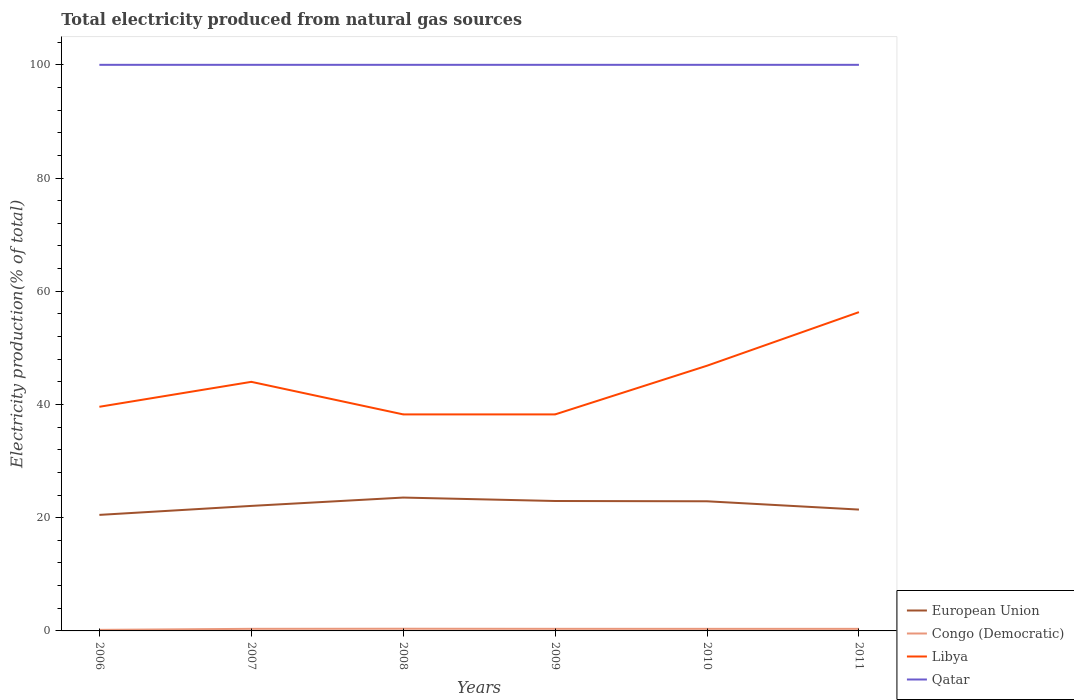How many different coloured lines are there?
Make the answer very short. 4. Does the line corresponding to Libya intersect with the line corresponding to European Union?
Ensure brevity in your answer.  No. Across all years, what is the maximum total electricity produced in European Union?
Provide a succinct answer. 20.5. In which year was the total electricity produced in European Union maximum?
Make the answer very short. 2006. What is the total total electricity produced in European Union in the graph?
Offer a very short reply. 0.66. What is the difference between the highest and the second highest total electricity produced in Qatar?
Give a very brief answer. 0. What is the difference between the highest and the lowest total electricity produced in European Union?
Provide a short and direct response. 3. Is the total electricity produced in Congo (Democratic) strictly greater than the total electricity produced in Libya over the years?
Provide a short and direct response. Yes. How many years are there in the graph?
Provide a short and direct response. 6. Are the values on the major ticks of Y-axis written in scientific E-notation?
Ensure brevity in your answer.  No. Where does the legend appear in the graph?
Your answer should be compact. Bottom right. How are the legend labels stacked?
Ensure brevity in your answer.  Vertical. What is the title of the graph?
Provide a short and direct response. Total electricity produced from natural gas sources. Does "Germany" appear as one of the legend labels in the graph?
Make the answer very short. No. What is the label or title of the X-axis?
Your response must be concise. Years. What is the Electricity production(% of total) in European Union in 2006?
Your response must be concise. 20.5. What is the Electricity production(% of total) of Congo (Democratic) in 2006?
Make the answer very short. 0.19. What is the Electricity production(% of total) in Libya in 2006?
Offer a very short reply. 39.59. What is the Electricity production(% of total) of Qatar in 2006?
Your response must be concise. 100. What is the Electricity production(% of total) in European Union in 2007?
Make the answer very short. 22.08. What is the Electricity production(% of total) in Congo (Democratic) in 2007?
Ensure brevity in your answer.  0.37. What is the Electricity production(% of total) in Libya in 2007?
Your response must be concise. 44. What is the Electricity production(% of total) in Qatar in 2007?
Ensure brevity in your answer.  100. What is the Electricity production(% of total) in European Union in 2008?
Provide a succinct answer. 23.56. What is the Electricity production(% of total) in Congo (Democratic) in 2008?
Your answer should be compact. 0.39. What is the Electricity production(% of total) of Libya in 2008?
Provide a succinct answer. 38.25. What is the Electricity production(% of total) of Qatar in 2008?
Your response must be concise. 100. What is the Electricity production(% of total) in European Union in 2009?
Make the answer very short. 22.95. What is the Electricity production(% of total) of Congo (Democratic) in 2009?
Your response must be concise. 0.37. What is the Electricity production(% of total) in Libya in 2009?
Provide a succinct answer. 38.25. What is the Electricity production(% of total) of European Union in 2010?
Make the answer very short. 22.9. What is the Electricity production(% of total) in Congo (Democratic) in 2010?
Ensure brevity in your answer.  0.37. What is the Electricity production(% of total) of Libya in 2010?
Keep it short and to the point. 46.85. What is the Electricity production(% of total) in Qatar in 2010?
Give a very brief answer. 100. What is the Electricity production(% of total) of European Union in 2011?
Your answer should be very brief. 21.43. What is the Electricity production(% of total) in Congo (Democratic) in 2011?
Make the answer very short. 0.37. What is the Electricity production(% of total) in Libya in 2011?
Offer a very short reply. 56.31. What is the Electricity production(% of total) of Qatar in 2011?
Your answer should be compact. 100. Across all years, what is the maximum Electricity production(% of total) in European Union?
Offer a terse response. 23.56. Across all years, what is the maximum Electricity production(% of total) of Congo (Democratic)?
Offer a very short reply. 0.39. Across all years, what is the maximum Electricity production(% of total) of Libya?
Provide a succinct answer. 56.31. Across all years, what is the maximum Electricity production(% of total) in Qatar?
Provide a short and direct response. 100. Across all years, what is the minimum Electricity production(% of total) in European Union?
Ensure brevity in your answer.  20.5. Across all years, what is the minimum Electricity production(% of total) in Congo (Democratic)?
Your response must be concise. 0.19. Across all years, what is the minimum Electricity production(% of total) in Libya?
Keep it short and to the point. 38.25. What is the total Electricity production(% of total) in European Union in the graph?
Your answer should be very brief. 133.42. What is the total Electricity production(% of total) in Congo (Democratic) in the graph?
Your answer should be very brief. 2.05. What is the total Electricity production(% of total) in Libya in the graph?
Provide a succinct answer. 263.25. What is the total Electricity production(% of total) in Qatar in the graph?
Keep it short and to the point. 600. What is the difference between the Electricity production(% of total) in European Union in 2006 and that in 2007?
Provide a succinct answer. -1.59. What is the difference between the Electricity production(% of total) in Congo (Democratic) in 2006 and that in 2007?
Your answer should be very brief. -0.18. What is the difference between the Electricity production(% of total) in Libya in 2006 and that in 2007?
Provide a succinct answer. -4.41. What is the difference between the Electricity production(% of total) in European Union in 2006 and that in 2008?
Offer a terse response. -3.06. What is the difference between the Electricity production(% of total) of Congo (Democratic) in 2006 and that in 2008?
Your answer should be very brief. -0.2. What is the difference between the Electricity production(% of total) in Libya in 2006 and that in 2008?
Provide a succinct answer. 1.35. What is the difference between the Electricity production(% of total) in European Union in 2006 and that in 2009?
Your answer should be compact. -2.45. What is the difference between the Electricity production(% of total) of Congo (Democratic) in 2006 and that in 2009?
Provide a succinct answer. -0.18. What is the difference between the Electricity production(% of total) in Libya in 2006 and that in 2009?
Keep it short and to the point. 1.35. What is the difference between the Electricity production(% of total) of Qatar in 2006 and that in 2009?
Offer a terse response. 0. What is the difference between the Electricity production(% of total) of European Union in 2006 and that in 2010?
Make the answer very short. -2.4. What is the difference between the Electricity production(% of total) in Congo (Democratic) in 2006 and that in 2010?
Your answer should be very brief. -0.18. What is the difference between the Electricity production(% of total) of Libya in 2006 and that in 2010?
Keep it short and to the point. -7.25. What is the difference between the Electricity production(% of total) of European Union in 2006 and that in 2011?
Give a very brief answer. -0.94. What is the difference between the Electricity production(% of total) in Congo (Democratic) in 2006 and that in 2011?
Your answer should be compact. -0.18. What is the difference between the Electricity production(% of total) of Libya in 2006 and that in 2011?
Provide a succinct answer. -16.72. What is the difference between the Electricity production(% of total) in Qatar in 2006 and that in 2011?
Make the answer very short. 0. What is the difference between the Electricity production(% of total) of European Union in 2007 and that in 2008?
Give a very brief answer. -1.47. What is the difference between the Electricity production(% of total) of Congo (Democratic) in 2007 and that in 2008?
Offer a very short reply. -0.02. What is the difference between the Electricity production(% of total) in Libya in 2007 and that in 2008?
Provide a succinct answer. 5.75. What is the difference between the Electricity production(% of total) of European Union in 2007 and that in 2009?
Make the answer very short. -0.87. What is the difference between the Electricity production(% of total) of Congo (Democratic) in 2007 and that in 2009?
Make the answer very short. -0. What is the difference between the Electricity production(% of total) of Libya in 2007 and that in 2009?
Your response must be concise. 5.75. What is the difference between the Electricity production(% of total) in European Union in 2007 and that in 2010?
Make the answer very short. -0.82. What is the difference between the Electricity production(% of total) of Congo (Democratic) in 2007 and that in 2010?
Your answer should be compact. 0. What is the difference between the Electricity production(% of total) of Libya in 2007 and that in 2010?
Offer a very short reply. -2.85. What is the difference between the Electricity production(% of total) in European Union in 2007 and that in 2011?
Your answer should be very brief. 0.65. What is the difference between the Electricity production(% of total) of Congo (Democratic) in 2007 and that in 2011?
Your answer should be very brief. 0. What is the difference between the Electricity production(% of total) in Libya in 2007 and that in 2011?
Keep it short and to the point. -12.31. What is the difference between the Electricity production(% of total) of Qatar in 2007 and that in 2011?
Offer a very short reply. 0. What is the difference between the Electricity production(% of total) in European Union in 2008 and that in 2009?
Provide a succinct answer. 0.61. What is the difference between the Electricity production(% of total) in Congo (Democratic) in 2008 and that in 2009?
Ensure brevity in your answer.  0.01. What is the difference between the Electricity production(% of total) of Libya in 2008 and that in 2009?
Offer a very short reply. -0. What is the difference between the Electricity production(% of total) of European Union in 2008 and that in 2010?
Give a very brief answer. 0.66. What is the difference between the Electricity production(% of total) of Congo (Democratic) in 2008 and that in 2010?
Give a very brief answer. 0.02. What is the difference between the Electricity production(% of total) in Libya in 2008 and that in 2010?
Provide a succinct answer. -8.6. What is the difference between the Electricity production(% of total) of European Union in 2008 and that in 2011?
Your answer should be very brief. 2.12. What is the difference between the Electricity production(% of total) of Congo (Democratic) in 2008 and that in 2011?
Your response must be concise. 0.02. What is the difference between the Electricity production(% of total) of Libya in 2008 and that in 2011?
Offer a terse response. -18.06. What is the difference between the Electricity production(% of total) of Qatar in 2008 and that in 2011?
Make the answer very short. 0. What is the difference between the Electricity production(% of total) of European Union in 2009 and that in 2010?
Your answer should be compact. 0.05. What is the difference between the Electricity production(% of total) in Congo (Democratic) in 2009 and that in 2010?
Make the answer very short. 0. What is the difference between the Electricity production(% of total) in Libya in 2009 and that in 2010?
Provide a succinct answer. -8.6. What is the difference between the Electricity production(% of total) of European Union in 2009 and that in 2011?
Your answer should be compact. 1.52. What is the difference between the Electricity production(% of total) in Congo (Democratic) in 2009 and that in 2011?
Provide a short and direct response. 0. What is the difference between the Electricity production(% of total) of Libya in 2009 and that in 2011?
Your response must be concise. -18.06. What is the difference between the Electricity production(% of total) of Qatar in 2009 and that in 2011?
Make the answer very short. 0. What is the difference between the Electricity production(% of total) of European Union in 2010 and that in 2011?
Offer a terse response. 1.47. What is the difference between the Electricity production(% of total) of Congo (Democratic) in 2010 and that in 2011?
Offer a terse response. -0. What is the difference between the Electricity production(% of total) in Libya in 2010 and that in 2011?
Give a very brief answer. -9.46. What is the difference between the Electricity production(% of total) of Qatar in 2010 and that in 2011?
Provide a succinct answer. 0. What is the difference between the Electricity production(% of total) in European Union in 2006 and the Electricity production(% of total) in Congo (Democratic) in 2007?
Give a very brief answer. 20.13. What is the difference between the Electricity production(% of total) of European Union in 2006 and the Electricity production(% of total) of Libya in 2007?
Offer a terse response. -23.5. What is the difference between the Electricity production(% of total) in European Union in 2006 and the Electricity production(% of total) in Qatar in 2007?
Provide a succinct answer. -79.5. What is the difference between the Electricity production(% of total) of Congo (Democratic) in 2006 and the Electricity production(% of total) of Libya in 2007?
Offer a very short reply. -43.81. What is the difference between the Electricity production(% of total) in Congo (Democratic) in 2006 and the Electricity production(% of total) in Qatar in 2007?
Make the answer very short. -99.81. What is the difference between the Electricity production(% of total) of Libya in 2006 and the Electricity production(% of total) of Qatar in 2007?
Give a very brief answer. -60.41. What is the difference between the Electricity production(% of total) in European Union in 2006 and the Electricity production(% of total) in Congo (Democratic) in 2008?
Give a very brief answer. 20.11. What is the difference between the Electricity production(% of total) in European Union in 2006 and the Electricity production(% of total) in Libya in 2008?
Your answer should be very brief. -17.75. What is the difference between the Electricity production(% of total) in European Union in 2006 and the Electricity production(% of total) in Qatar in 2008?
Give a very brief answer. -79.5. What is the difference between the Electricity production(% of total) in Congo (Democratic) in 2006 and the Electricity production(% of total) in Libya in 2008?
Offer a terse response. -38.06. What is the difference between the Electricity production(% of total) in Congo (Democratic) in 2006 and the Electricity production(% of total) in Qatar in 2008?
Ensure brevity in your answer.  -99.81. What is the difference between the Electricity production(% of total) of Libya in 2006 and the Electricity production(% of total) of Qatar in 2008?
Offer a terse response. -60.41. What is the difference between the Electricity production(% of total) in European Union in 2006 and the Electricity production(% of total) in Congo (Democratic) in 2009?
Your answer should be compact. 20.13. What is the difference between the Electricity production(% of total) of European Union in 2006 and the Electricity production(% of total) of Libya in 2009?
Provide a succinct answer. -17.75. What is the difference between the Electricity production(% of total) in European Union in 2006 and the Electricity production(% of total) in Qatar in 2009?
Keep it short and to the point. -79.5. What is the difference between the Electricity production(% of total) in Congo (Democratic) in 2006 and the Electricity production(% of total) in Libya in 2009?
Keep it short and to the point. -38.06. What is the difference between the Electricity production(% of total) in Congo (Democratic) in 2006 and the Electricity production(% of total) in Qatar in 2009?
Ensure brevity in your answer.  -99.81. What is the difference between the Electricity production(% of total) of Libya in 2006 and the Electricity production(% of total) of Qatar in 2009?
Offer a very short reply. -60.41. What is the difference between the Electricity production(% of total) in European Union in 2006 and the Electricity production(% of total) in Congo (Democratic) in 2010?
Provide a short and direct response. 20.13. What is the difference between the Electricity production(% of total) of European Union in 2006 and the Electricity production(% of total) of Libya in 2010?
Ensure brevity in your answer.  -26.35. What is the difference between the Electricity production(% of total) of European Union in 2006 and the Electricity production(% of total) of Qatar in 2010?
Provide a short and direct response. -79.5. What is the difference between the Electricity production(% of total) of Congo (Democratic) in 2006 and the Electricity production(% of total) of Libya in 2010?
Your response must be concise. -46.66. What is the difference between the Electricity production(% of total) of Congo (Democratic) in 2006 and the Electricity production(% of total) of Qatar in 2010?
Provide a short and direct response. -99.81. What is the difference between the Electricity production(% of total) of Libya in 2006 and the Electricity production(% of total) of Qatar in 2010?
Provide a succinct answer. -60.41. What is the difference between the Electricity production(% of total) of European Union in 2006 and the Electricity production(% of total) of Congo (Democratic) in 2011?
Make the answer very short. 20.13. What is the difference between the Electricity production(% of total) in European Union in 2006 and the Electricity production(% of total) in Libya in 2011?
Give a very brief answer. -35.81. What is the difference between the Electricity production(% of total) of European Union in 2006 and the Electricity production(% of total) of Qatar in 2011?
Offer a terse response. -79.5. What is the difference between the Electricity production(% of total) of Congo (Democratic) in 2006 and the Electricity production(% of total) of Libya in 2011?
Provide a short and direct response. -56.13. What is the difference between the Electricity production(% of total) in Congo (Democratic) in 2006 and the Electricity production(% of total) in Qatar in 2011?
Your answer should be very brief. -99.81. What is the difference between the Electricity production(% of total) in Libya in 2006 and the Electricity production(% of total) in Qatar in 2011?
Make the answer very short. -60.41. What is the difference between the Electricity production(% of total) of European Union in 2007 and the Electricity production(% of total) of Congo (Democratic) in 2008?
Ensure brevity in your answer.  21.7. What is the difference between the Electricity production(% of total) of European Union in 2007 and the Electricity production(% of total) of Libya in 2008?
Make the answer very short. -16.16. What is the difference between the Electricity production(% of total) in European Union in 2007 and the Electricity production(% of total) in Qatar in 2008?
Your answer should be very brief. -77.92. What is the difference between the Electricity production(% of total) in Congo (Democratic) in 2007 and the Electricity production(% of total) in Libya in 2008?
Provide a short and direct response. -37.88. What is the difference between the Electricity production(% of total) of Congo (Democratic) in 2007 and the Electricity production(% of total) of Qatar in 2008?
Provide a succinct answer. -99.63. What is the difference between the Electricity production(% of total) of Libya in 2007 and the Electricity production(% of total) of Qatar in 2008?
Your response must be concise. -56. What is the difference between the Electricity production(% of total) in European Union in 2007 and the Electricity production(% of total) in Congo (Democratic) in 2009?
Ensure brevity in your answer.  21.71. What is the difference between the Electricity production(% of total) in European Union in 2007 and the Electricity production(% of total) in Libya in 2009?
Give a very brief answer. -16.16. What is the difference between the Electricity production(% of total) in European Union in 2007 and the Electricity production(% of total) in Qatar in 2009?
Make the answer very short. -77.92. What is the difference between the Electricity production(% of total) in Congo (Democratic) in 2007 and the Electricity production(% of total) in Libya in 2009?
Your answer should be very brief. -37.88. What is the difference between the Electricity production(% of total) of Congo (Democratic) in 2007 and the Electricity production(% of total) of Qatar in 2009?
Ensure brevity in your answer.  -99.63. What is the difference between the Electricity production(% of total) of Libya in 2007 and the Electricity production(% of total) of Qatar in 2009?
Keep it short and to the point. -56. What is the difference between the Electricity production(% of total) in European Union in 2007 and the Electricity production(% of total) in Congo (Democratic) in 2010?
Ensure brevity in your answer.  21.72. What is the difference between the Electricity production(% of total) in European Union in 2007 and the Electricity production(% of total) in Libya in 2010?
Offer a terse response. -24.76. What is the difference between the Electricity production(% of total) of European Union in 2007 and the Electricity production(% of total) of Qatar in 2010?
Your answer should be compact. -77.92. What is the difference between the Electricity production(% of total) in Congo (Democratic) in 2007 and the Electricity production(% of total) in Libya in 2010?
Your answer should be very brief. -46.48. What is the difference between the Electricity production(% of total) of Congo (Democratic) in 2007 and the Electricity production(% of total) of Qatar in 2010?
Make the answer very short. -99.63. What is the difference between the Electricity production(% of total) of Libya in 2007 and the Electricity production(% of total) of Qatar in 2010?
Your response must be concise. -56. What is the difference between the Electricity production(% of total) of European Union in 2007 and the Electricity production(% of total) of Congo (Democratic) in 2011?
Keep it short and to the point. 21.72. What is the difference between the Electricity production(% of total) in European Union in 2007 and the Electricity production(% of total) in Libya in 2011?
Provide a short and direct response. -34.23. What is the difference between the Electricity production(% of total) in European Union in 2007 and the Electricity production(% of total) in Qatar in 2011?
Your response must be concise. -77.92. What is the difference between the Electricity production(% of total) in Congo (Democratic) in 2007 and the Electricity production(% of total) in Libya in 2011?
Provide a succinct answer. -55.94. What is the difference between the Electricity production(% of total) of Congo (Democratic) in 2007 and the Electricity production(% of total) of Qatar in 2011?
Your response must be concise. -99.63. What is the difference between the Electricity production(% of total) of Libya in 2007 and the Electricity production(% of total) of Qatar in 2011?
Offer a very short reply. -56. What is the difference between the Electricity production(% of total) in European Union in 2008 and the Electricity production(% of total) in Congo (Democratic) in 2009?
Keep it short and to the point. 23.19. What is the difference between the Electricity production(% of total) of European Union in 2008 and the Electricity production(% of total) of Libya in 2009?
Give a very brief answer. -14.69. What is the difference between the Electricity production(% of total) of European Union in 2008 and the Electricity production(% of total) of Qatar in 2009?
Your answer should be very brief. -76.44. What is the difference between the Electricity production(% of total) of Congo (Democratic) in 2008 and the Electricity production(% of total) of Libya in 2009?
Provide a short and direct response. -37.86. What is the difference between the Electricity production(% of total) of Congo (Democratic) in 2008 and the Electricity production(% of total) of Qatar in 2009?
Provide a short and direct response. -99.61. What is the difference between the Electricity production(% of total) of Libya in 2008 and the Electricity production(% of total) of Qatar in 2009?
Your answer should be compact. -61.75. What is the difference between the Electricity production(% of total) in European Union in 2008 and the Electricity production(% of total) in Congo (Democratic) in 2010?
Make the answer very short. 23.19. What is the difference between the Electricity production(% of total) of European Union in 2008 and the Electricity production(% of total) of Libya in 2010?
Your answer should be very brief. -23.29. What is the difference between the Electricity production(% of total) of European Union in 2008 and the Electricity production(% of total) of Qatar in 2010?
Keep it short and to the point. -76.44. What is the difference between the Electricity production(% of total) in Congo (Democratic) in 2008 and the Electricity production(% of total) in Libya in 2010?
Give a very brief answer. -46.46. What is the difference between the Electricity production(% of total) of Congo (Democratic) in 2008 and the Electricity production(% of total) of Qatar in 2010?
Your answer should be compact. -99.61. What is the difference between the Electricity production(% of total) of Libya in 2008 and the Electricity production(% of total) of Qatar in 2010?
Offer a terse response. -61.75. What is the difference between the Electricity production(% of total) in European Union in 2008 and the Electricity production(% of total) in Congo (Democratic) in 2011?
Make the answer very short. 23.19. What is the difference between the Electricity production(% of total) of European Union in 2008 and the Electricity production(% of total) of Libya in 2011?
Offer a very short reply. -32.76. What is the difference between the Electricity production(% of total) of European Union in 2008 and the Electricity production(% of total) of Qatar in 2011?
Provide a short and direct response. -76.44. What is the difference between the Electricity production(% of total) in Congo (Democratic) in 2008 and the Electricity production(% of total) in Libya in 2011?
Your answer should be very brief. -55.93. What is the difference between the Electricity production(% of total) of Congo (Democratic) in 2008 and the Electricity production(% of total) of Qatar in 2011?
Your answer should be compact. -99.61. What is the difference between the Electricity production(% of total) of Libya in 2008 and the Electricity production(% of total) of Qatar in 2011?
Offer a terse response. -61.75. What is the difference between the Electricity production(% of total) of European Union in 2009 and the Electricity production(% of total) of Congo (Democratic) in 2010?
Offer a terse response. 22.58. What is the difference between the Electricity production(% of total) in European Union in 2009 and the Electricity production(% of total) in Libya in 2010?
Make the answer very short. -23.9. What is the difference between the Electricity production(% of total) of European Union in 2009 and the Electricity production(% of total) of Qatar in 2010?
Give a very brief answer. -77.05. What is the difference between the Electricity production(% of total) of Congo (Democratic) in 2009 and the Electricity production(% of total) of Libya in 2010?
Keep it short and to the point. -46.48. What is the difference between the Electricity production(% of total) in Congo (Democratic) in 2009 and the Electricity production(% of total) in Qatar in 2010?
Keep it short and to the point. -99.63. What is the difference between the Electricity production(% of total) in Libya in 2009 and the Electricity production(% of total) in Qatar in 2010?
Make the answer very short. -61.75. What is the difference between the Electricity production(% of total) in European Union in 2009 and the Electricity production(% of total) in Congo (Democratic) in 2011?
Your answer should be very brief. 22.58. What is the difference between the Electricity production(% of total) in European Union in 2009 and the Electricity production(% of total) in Libya in 2011?
Provide a short and direct response. -33.36. What is the difference between the Electricity production(% of total) of European Union in 2009 and the Electricity production(% of total) of Qatar in 2011?
Ensure brevity in your answer.  -77.05. What is the difference between the Electricity production(% of total) of Congo (Democratic) in 2009 and the Electricity production(% of total) of Libya in 2011?
Provide a short and direct response. -55.94. What is the difference between the Electricity production(% of total) of Congo (Democratic) in 2009 and the Electricity production(% of total) of Qatar in 2011?
Offer a terse response. -99.63. What is the difference between the Electricity production(% of total) in Libya in 2009 and the Electricity production(% of total) in Qatar in 2011?
Offer a very short reply. -61.75. What is the difference between the Electricity production(% of total) of European Union in 2010 and the Electricity production(% of total) of Congo (Democratic) in 2011?
Provide a short and direct response. 22.53. What is the difference between the Electricity production(% of total) in European Union in 2010 and the Electricity production(% of total) in Libya in 2011?
Provide a succinct answer. -33.41. What is the difference between the Electricity production(% of total) in European Union in 2010 and the Electricity production(% of total) in Qatar in 2011?
Make the answer very short. -77.1. What is the difference between the Electricity production(% of total) of Congo (Democratic) in 2010 and the Electricity production(% of total) of Libya in 2011?
Provide a succinct answer. -55.94. What is the difference between the Electricity production(% of total) of Congo (Democratic) in 2010 and the Electricity production(% of total) of Qatar in 2011?
Ensure brevity in your answer.  -99.63. What is the difference between the Electricity production(% of total) of Libya in 2010 and the Electricity production(% of total) of Qatar in 2011?
Your response must be concise. -53.15. What is the average Electricity production(% of total) in European Union per year?
Offer a terse response. 22.24. What is the average Electricity production(% of total) in Congo (Democratic) per year?
Your answer should be very brief. 0.34. What is the average Electricity production(% of total) in Libya per year?
Offer a very short reply. 43.87. What is the average Electricity production(% of total) of Qatar per year?
Offer a very short reply. 100. In the year 2006, what is the difference between the Electricity production(% of total) of European Union and Electricity production(% of total) of Congo (Democratic)?
Ensure brevity in your answer.  20.31. In the year 2006, what is the difference between the Electricity production(% of total) in European Union and Electricity production(% of total) in Libya?
Make the answer very short. -19.1. In the year 2006, what is the difference between the Electricity production(% of total) of European Union and Electricity production(% of total) of Qatar?
Your answer should be compact. -79.5. In the year 2006, what is the difference between the Electricity production(% of total) of Congo (Democratic) and Electricity production(% of total) of Libya?
Your response must be concise. -39.41. In the year 2006, what is the difference between the Electricity production(% of total) of Congo (Democratic) and Electricity production(% of total) of Qatar?
Provide a short and direct response. -99.81. In the year 2006, what is the difference between the Electricity production(% of total) in Libya and Electricity production(% of total) in Qatar?
Your answer should be compact. -60.41. In the year 2007, what is the difference between the Electricity production(% of total) of European Union and Electricity production(% of total) of Congo (Democratic)?
Your answer should be compact. 21.71. In the year 2007, what is the difference between the Electricity production(% of total) of European Union and Electricity production(% of total) of Libya?
Offer a very short reply. -21.92. In the year 2007, what is the difference between the Electricity production(% of total) in European Union and Electricity production(% of total) in Qatar?
Provide a short and direct response. -77.92. In the year 2007, what is the difference between the Electricity production(% of total) in Congo (Democratic) and Electricity production(% of total) in Libya?
Make the answer very short. -43.63. In the year 2007, what is the difference between the Electricity production(% of total) of Congo (Democratic) and Electricity production(% of total) of Qatar?
Give a very brief answer. -99.63. In the year 2007, what is the difference between the Electricity production(% of total) of Libya and Electricity production(% of total) of Qatar?
Your answer should be compact. -56. In the year 2008, what is the difference between the Electricity production(% of total) in European Union and Electricity production(% of total) in Congo (Democratic)?
Your response must be concise. 23.17. In the year 2008, what is the difference between the Electricity production(% of total) in European Union and Electricity production(% of total) in Libya?
Your answer should be compact. -14.69. In the year 2008, what is the difference between the Electricity production(% of total) of European Union and Electricity production(% of total) of Qatar?
Provide a succinct answer. -76.44. In the year 2008, what is the difference between the Electricity production(% of total) of Congo (Democratic) and Electricity production(% of total) of Libya?
Your answer should be very brief. -37.86. In the year 2008, what is the difference between the Electricity production(% of total) of Congo (Democratic) and Electricity production(% of total) of Qatar?
Provide a short and direct response. -99.61. In the year 2008, what is the difference between the Electricity production(% of total) of Libya and Electricity production(% of total) of Qatar?
Provide a short and direct response. -61.75. In the year 2009, what is the difference between the Electricity production(% of total) of European Union and Electricity production(% of total) of Congo (Democratic)?
Give a very brief answer. 22.58. In the year 2009, what is the difference between the Electricity production(% of total) in European Union and Electricity production(% of total) in Libya?
Give a very brief answer. -15.3. In the year 2009, what is the difference between the Electricity production(% of total) of European Union and Electricity production(% of total) of Qatar?
Provide a succinct answer. -77.05. In the year 2009, what is the difference between the Electricity production(% of total) of Congo (Democratic) and Electricity production(% of total) of Libya?
Your answer should be very brief. -37.88. In the year 2009, what is the difference between the Electricity production(% of total) in Congo (Democratic) and Electricity production(% of total) in Qatar?
Provide a short and direct response. -99.63. In the year 2009, what is the difference between the Electricity production(% of total) in Libya and Electricity production(% of total) in Qatar?
Provide a short and direct response. -61.75. In the year 2010, what is the difference between the Electricity production(% of total) in European Union and Electricity production(% of total) in Congo (Democratic)?
Offer a very short reply. 22.53. In the year 2010, what is the difference between the Electricity production(% of total) in European Union and Electricity production(% of total) in Libya?
Ensure brevity in your answer.  -23.95. In the year 2010, what is the difference between the Electricity production(% of total) in European Union and Electricity production(% of total) in Qatar?
Provide a short and direct response. -77.1. In the year 2010, what is the difference between the Electricity production(% of total) in Congo (Democratic) and Electricity production(% of total) in Libya?
Offer a very short reply. -46.48. In the year 2010, what is the difference between the Electricity production(% of total) of Congo (Democratic) and Electricity production(% of total) of Qatar?
Provide a short and direct response. -99.63. In the year 2010, what is the difference between the Electricity production(% of total) of Libya and Electricity production(% of total) of Qatar?
Make the answer very short. -53.15. In the year 2011, what is the difference between the Electricity production(% of total) in European Union and Electricity production(% of total) in Congo (Democratic)?
Provide a short and direct response. 21.07. In the year 2011, what is the difference between the Electricity production(% of total) of European Union and Electricity production(% of total) of Libya?
Keep it short and to the point. -34.88. In the year 2011, what is the difference between the Electricity production(% of total) of European Union and Electricity production(% of total) of Qatar?
Your answer should be compact. -78.57. In the year 2011, what is the difference between the Electricity production(% of total) in Congo (Democratic) and Electricity production(% of total) in Libya?
Keep it short and to the point. -55.94. In the year 2011, what is the difference between the Electricity production(% of total) of Congo (Democratic) and Electricity production(% of total) of Qatar?
Your answer should be compact. -99.63. In the year 2011, what is the difference between the Electricity production(% of total) of Libya and Electricity production(% of total) of Qatar?
Ensure brevity in your answer.  -43.69. What is the ratio of the Electricity production(% of total) in European Union in 2006 to that in 2007?
Ensure brevity in your answer.  0.93. What is the ratio of the Electricity production(% of total) of Congo (Democratic) in 2006 to that in 2007?
Make the answer very short. 0.5. What is the ratio of the Electricity production(% of total) of Libya in 2006 to that in 2007?
Offer a very short reply. 0.9. What is the ratio of the Electricity production(% of total) of Qatar in 2006 to that in 2007?
Your response must be concise. 1. What is the ratio of the Electricity production(% of total) of European Union in 2006 to that in 2008?
Your answer should be very brief. 0.87. What is the ratio of the Electricity production(% of total) in Congo (Democratic) in 2006 to that in 2008?
Provide a short and direct response. 0.48. What is the ratio of the Electricity production(% of total) of Libya in 2006 to that in 2008?
Your response must be concise. 1.04. What is the ratio of the Electricity production(% of total) of Qatar in 2006 to that in 2008?
Give a very brief answer. 1. What is the ratio of the Electricity production(% of total) in European Union in 2006 to that in 2009?
Keep it short and to the point. 0.89. What is the ratio of the Electricity production(% of total) of Congo (Democratic) in 2006 to that in 2009?
Make the answer very short. 0.5. What is the ratio of the Electricity production(% of total) of Libya in 2006 to that in 2009?
Your answer should be compact. 1.04. What is the ratio of the Electricity production(% of total) of European Union in 2006 to that in 2010?
Provide a short and direct response. 0.9. What is the ratio of the Electricity production(% of total) of Congo (Democratic) in 2006 to that in 2010?
Give a very brief answer. 0.5. What is the ratio of the Electricity production(% of total) in Libya in 2006 to that in 2010?
Your answer should be compact. 0.85. What is the ratio of the Electricity production(% of total) of European Union in 2006 to that in 2011?
Give a very brief answer. 0.96. What is the ratio of the Electricity production(% of total) of Congo (Democratic) in 2006 to that in 2011?
Provide a succinct answer. 0.5. What is the ratio of the Electricity production(% of total) in Libya in 2006 to that in 2011?
Provide a succinct answer. 0.7. What is the ratio of the Electricity production(% of total) of Qatar in 2006 to that in 2011?
Your answer should be very brief. 1. What is the ratio of the Electricity production(% of total) of European Union in 2007 to that in 2008?
Offer a very short reply. 0.94. What is the ratio of the Electricity production(% of total) in Congo (Democratic) in 2007 to that in 2008?
Keep it short and to the point. 0.96. What is the ratio of the Electricity production(% of total) in Libya in 2007 to that in 2008?
Your answer should be compact. 1.15. What is the ratio of the Electricity production(% of total) of European Union in 2007 to that in 2009?
Keep it short and to the point. 0.96. What is the ratio of the Electricity production(% of total) of Libya in 2007 to that in 2009?
Keep it short and to the point. 1.15. What is the ratio of the Electricity production(% of total) in Congo (Democratic) in 2007 to that in 2010?
Keep it short and to the point. 1. What is the ratio of the Electricity production(% of total) of Libya in 2007 to that in 2010?
Your answer should be compact. 0.94. What is the ratio of the Electricity production(% of total) of Qatar in 2007 to that in 2010?
Give a very brief answer. 1. What is the ratio of the Electricity production(% of total) in European Union in 2007 to that in 2011?
Make the answer very short. 1.03. What is the ratio of the Electricity production(% of total) of Congo (Democratic) in 2007 to that in 2011?
Your answer should be compact. 1. What is the ratio of the Electricity production(% of total) in Libya in 2007 to that in 2011?
Offer a very short reply. 0.78. What is the ratio of the Electricity production(% of total) in European Union in 2008 to that in 2009?
Provide a short and direct response. 1.03. What is the ratio of the Electricity production(% of total) in Congo (Democratic) in 2008 to that in 2009?
Offer a very short reply. 1.04. What is the ratio of the Electricity production(% of total) of Libya in 2008 to that in 2009?
Ensure brevity in your answer.  1. What is the ratio of the Electricity production(% of total) of Qatar in 2008 to that in 2009?
Offer a very short reply. 1. What is the ratio of the Electricity production(% of total) in European Union in 2008 to that in 2010?
Provide a succinct answer. 1.03. What is the ratio of the Electricity production(% of total) of Congo (Democratic) in 2008 to that in 2010?
Make the answer very short. 1.05. What is the ratio of the Electricity production(% of total) of Libya in 2008 to that in 2010?
Provide a succinct answer. 0.82. What is the ratio of the Electricity production(% of total) of European Union in 2008 to that in 2011?
Provide a succinct answer. 1.1. What is the ratio of the Electricity production(% of total) in Congo (Democratic) in 2008 to that in 2011?
Your response must be concise. 1.05. What is the ratio of the Electricity production(% of total) in Libya in 2008 to that in 2011?
Your answer should be very brief. 0.68. What is the ratio of the Electricity production(% of total) in European Union in 2009 to that in 2010?
Give a very brief answer. 1. What is the ratio of the Electricity production(% of total) of Congo (Democratic) in 2009 to that in 2010?
Make the answer very short. 1.01. What is the ratio of the Electricity production(% of total) of Libya in 2009 to that in 2010?
Provide a short and direct response. 0.82. What is the ratio of the Electricity production(% of total) in European Union in 2009 to that in 2011?
Provide a succinct answer. 1.07. What is the ratio of the Electricity production(% of total) of Libya in 2009 to that in 2011?
Your response must be concise. 0.68. What is the ratio of the Electricity production(% of total) in Qatar in 2009 to that in 2011?
Offer a terse response. 1. What is the ratio of the Electricity production(% of total) in European Union in 2010 to that in 2011?
Offer a very short reply. 1.07. What is the ratio of the Electricity production(% of total) in Libya in 2010 to that in 2011?
Your answer should be compact. 0.83. What is the ratio of the Electricity production(% of total) of Qatar in 2010 to that in 2011?
Provide a short and direct response. 1. What is the difference between the highest and the second highest Electricity production(% of total) of European Union?
Provide a short and direct response. 0.61. What is the difference between the highest and the second highest Electricity production(% of total) in Congo (Democratic)?
Your answer should be compact. 0.01. What is the difference between the highest and the second highest Electricity production(% of total) of Libya?
Make the answer very short. 9.46. What is the difference between the highest and the lowest Electricity production(% of total) in European Union?
Your answer should be compact. 3.06. What is the difference between the highest and the lowest Electricity production(% of total) of Congo (Democratic)?
Offer a terse response. 0.2. What is the difference between the highest and the lowest Electricity production(% of total) of Libya?
Provide a succinct answer. 18.06. What is the difference between the highest and the lowest Electricity production(% of total) of Qatar?
Ensure brevity in your answer.  0. 